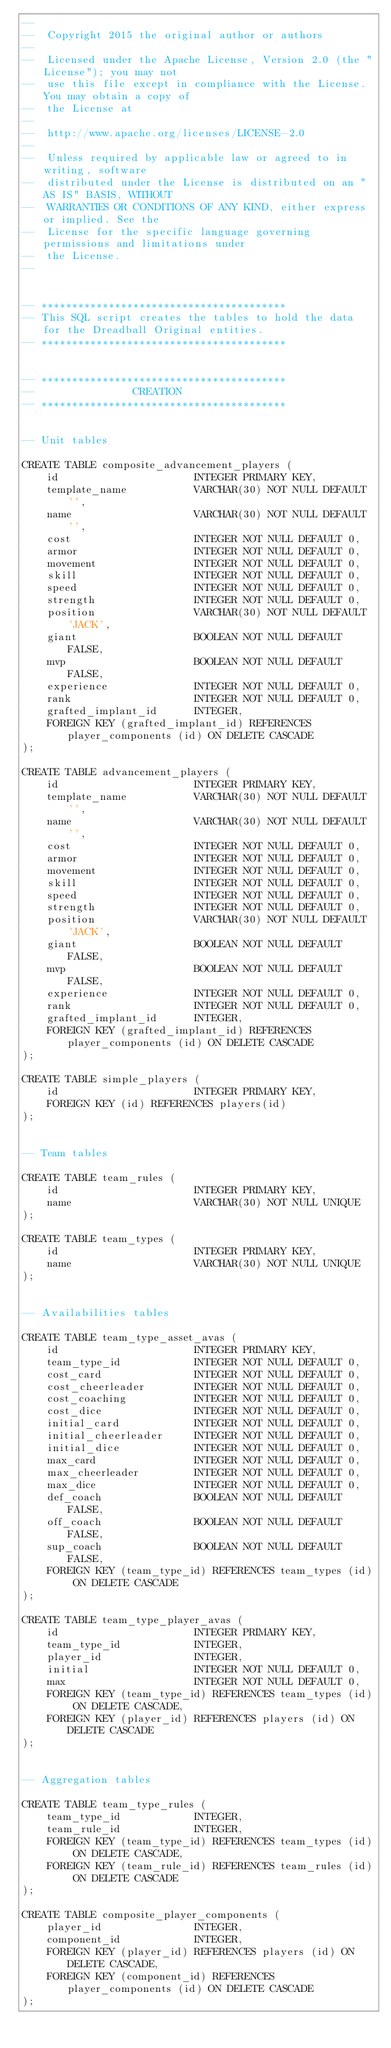Convert code to text. <code><loc_0><loc_0><loc_500><loc_500><_SQL_>--
--  Copyright 2015 the original author or authors
--
--  Licensed under the Apache License, Version 2.0 (the "License"); you may not
--  use this file except in compliance with the License. You may obtain a copy of
--  the License at
--
--  http://www.apache.org/licenses/LICENSE-2.0
--
--  Unless required by applicable law or agreed to in writing, software
--  distributed under the License is distributed on an "AS IS" BASIS, WITHOUT
--  WARRANTIES OR CONDITIONS OF ANY KIND, either express or implied. See the
--  License for the specific language governing permissions and limitations under
--  the License.
--


-- ****************************************
-- This SQL script creates the tables to hold the data for the Dreadball Original entities.
-- ****************************************


-- ****************************************
--                CREATION
-- ****************************************


-- Unit tables

CREATE TABLE composite_advancement_players (
    id                      INTEGER PRIMARY KEY,
    template_name           VARCHAR(30) NOT NULL DEFAULT '',
    name                    VARCHAR(30) NOT NULL DEFAULT '',
    cost                    INTEGER NOT NULL DEFAULT 0,
    armor                   INTEGER NOT NULL DEFAULT 0,
    movement                INTEGER NOT NULL DEFAULT 0,
    skill                   INTEGER NOT NULL DEFAULT 0,
    speed                   INTEGER NOT NULL DEFAULT 0,
    strength                INTEGER NOT NULL DEFAULT 0,
    position                VARCHAR(30) NOT NULL DEFAULT 'JACK',
    giant                   BOOLEAN NOT NULL DEFAULT FALSE,
    mvp                     BOOLEAN NOT NULL DEFAULT FALSE,
    experience              INTEGER NOT NULL DEFAULT 0,
    rank                    INTEGER NOT NULL DEFAULT 0,
    grafted_implant_id      INTEGER,
    FOREIGN KEY (grafted_implant_id) REFERENCES player_components (id) ON DELETE CASCADE
);

CREATE TABLE advancement_players (
    id                      INTEGER PRIMARY KEY,
    template_name           VARCHAR(30) NOT NULL DEFAULT '',
    name                    VARCHAR(30) NOT NULL DEFAULT '',
    cost                    INTEGER NOT NULL DEFAULT 0,
    armor                   INTEGER NOT NULL DEFAULT 0,
    movement                INTEGER NOT NULL DEFAULT 0,
    skill                   INTEGER NOT NULL DEFAULT 0,
    speed                   INTEGER NOT NULL DEFAULT 0,
    strength                INTEGER NOT NULL DEFAULT 0,
    position                VARCHAR(30) NOT NULL DEFAULT 'JACK',
    giant                   BOOLEAN NOT NULL DEFAULT FALSE,
    mvp                     BOOLEAN NOT NULL DEFAULT FALSE,
    experience              INTEGER NOT NULL DEFAULT 0,
    rank                    INTEGER NOT NULL DEFAULT 0,
    grafted_implant_id      INTEGER,
    FOREIGN KEY (grafted_implant_id) REFERENCES player_components (id) ON DELETE CASCADE
);

CREATE TABLE simple_players (
    id                      INTEGER PRIMARY KEY,
    FOREIGN KEY (id) REFERENCES players(id)
);


-- Team tables

CREATE TABLE team_rules (
    id                      INTEGER PRIMARY KEY,
    name                    VARCHAR(30) NOT NULL UNIQUE
);

CREATE TABLE team_types (
    id                      INTEGER PRIMARY KEY,
    name                    VARCHAR(30) NOT NULL UNIQUE
);


-- Availabilities tables

CREATE TABLE team_type_asset_avas (
    id                      INTEGER PRIMARY KEY,
    team_type_id            INTEGER NOT NULL DEFAULT 0,
    cost_card               INTEGER NOT NULL DEFAULT 0,
    cost_cheerleader        INTEGER NOT NULL DEFAULT 0,
    cost_coaching           INTEGER NOT NULL DEFAULT 0,
    cost_dice               INTEGER NOT NULL DEFAULT 0,
    initial_card            INTEGER NOT NULL DEFAULT 0,
    initial_cheerleader     INTEGER NOT NULL DEFAULT 0,
    initial_dice            INTEGER NOT NULL DEFAULT 0,
    max_card                INTEGER NOT NULL DEFAULT 0,
    max_cheerleader         INTEGER NOT NULL DEFAULT 0,
    max_dice                INTEGER NOT NULL DEFAULT 0,
    def_coach               BOOLEAN NOT NULL DEFAULT FALSE,
    off_coach               BOOLEAN NOT NULL DEFAULT FALSE,
    sup_coach               BOOLEAN NOT NULL DEFAULT FALSE,
    FOREIGN KEY (team_type_id) REFERENCES team_types (id) ON DELETE CASCADE
);

CREATE TABLE team_type_player_avas (
    id                      INTEGER PRIMARY KEY,
    team_type_id            INTEGER,
    player_id               INTEGER,
    initial                 INTEGER NOT NULL DEFAULT 0,
    max                     INTEGER NOT NULL DEFAULT 0,
    FOREIGN KEY (team_type_id) REFERENCES team_types (id) ON DELETE CASCADE,
    FOREIGN KEY (player_id) REFERENCES players (id) ON DELETE CASCADE
);


-- Aggregation tables

CREATE TABLE team_type_rules (
    team_type_id            INTEGER,
    team_rule_id            INTEGER,
    FOREIGN KEY (team_type_id) REFERENCES team_types (id) ON DELETE CASCADE,
    FOREIGN KEY (team_rule_id) REFERENCES team_rules (id) ON DELETE CASCADE
);

CREATE TABLE composite_player_components (
    player_id               INTEGER,
    component_id            INTEGER,
    FOREIGN KEY (player_id) REFERENCES players (id) ON DELETE CASCADE,
    FOREIGN KEY (component_id) REFERENCES player_components (id) ON DELETE CASCADE
);
</code> 